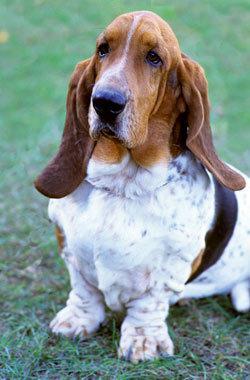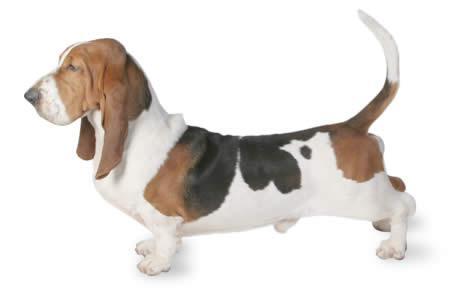The first image is the image on the left, the second image is the image on the right. For the images displayed, is the sentence "One image shows exactly two basset hounds." factually correct? Answer yes or no. No. 